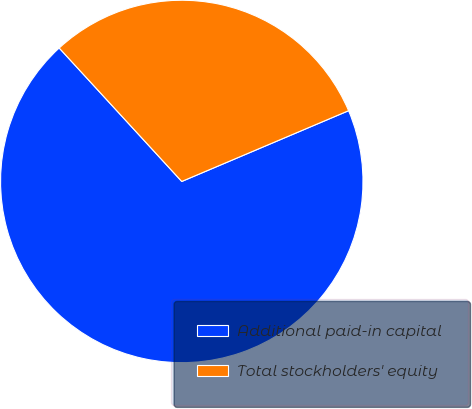Convert chart. <chart><loc_0><loc_0><loc_500><loc_500><pie_chart><fcel>Additional paid-in capital<fcel>Total stockholders' equity<nl><fcel>69.56%<fcel>30.44%<nl></chart> 